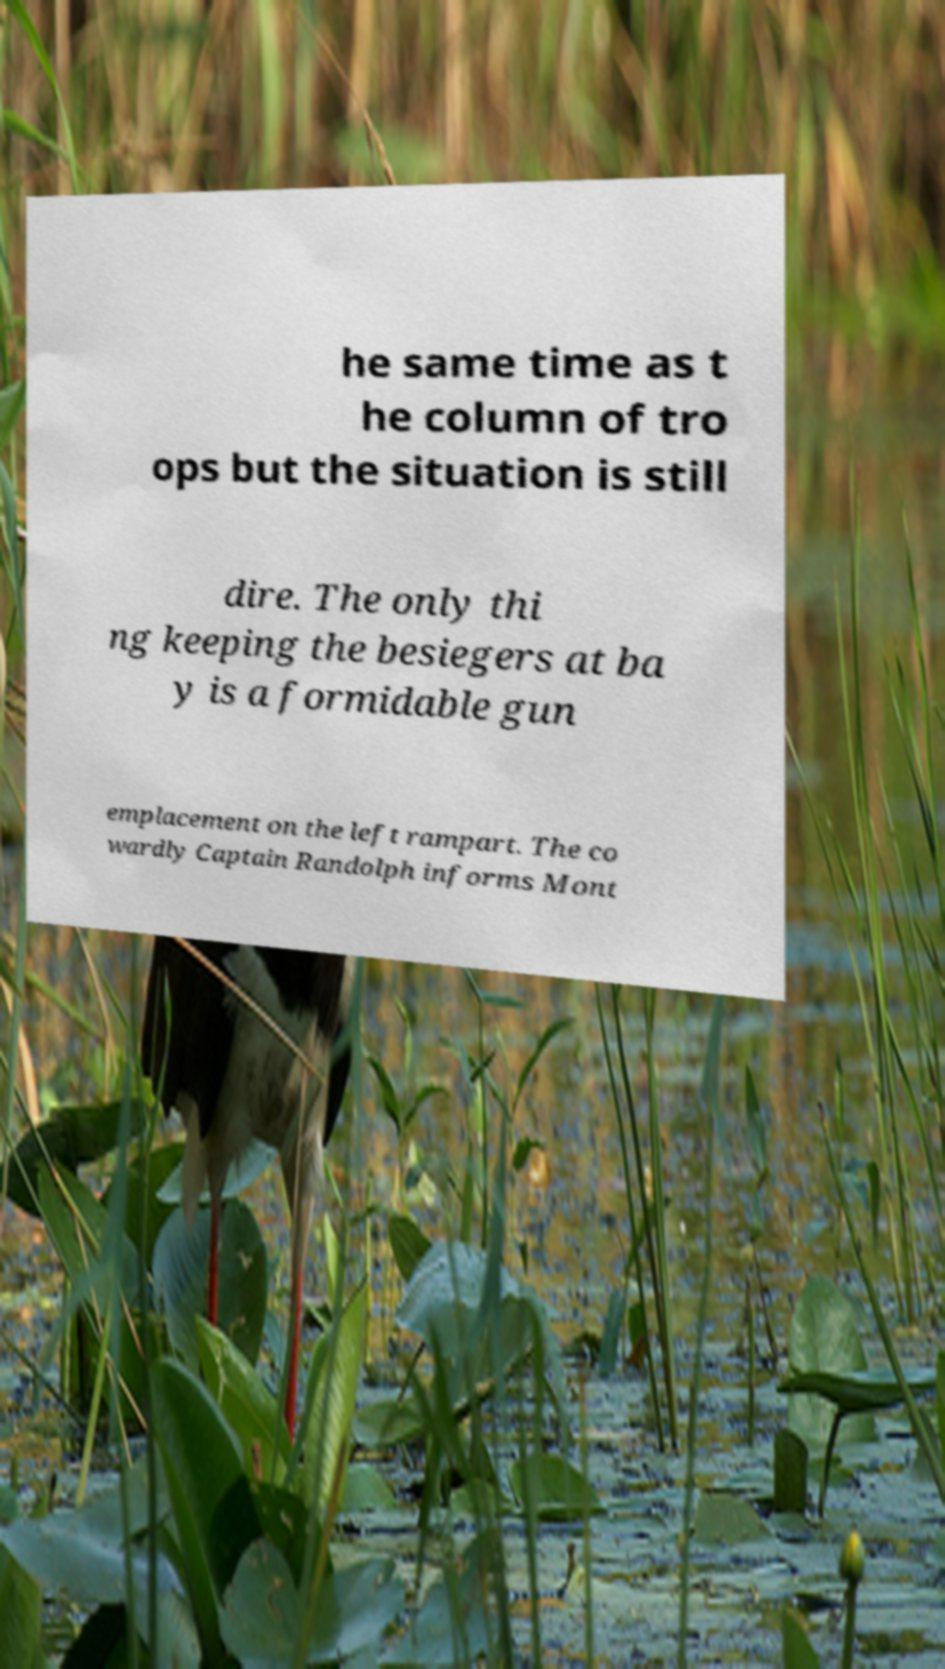Could you extract and type out the text from this image? he same time as t he column of tro ops but the situation is still dire. The only thi ng keeping the besiegers at ba y is a formidable gun emplacement on the left rampart. The co wardly Captain Randolph informs Mont 